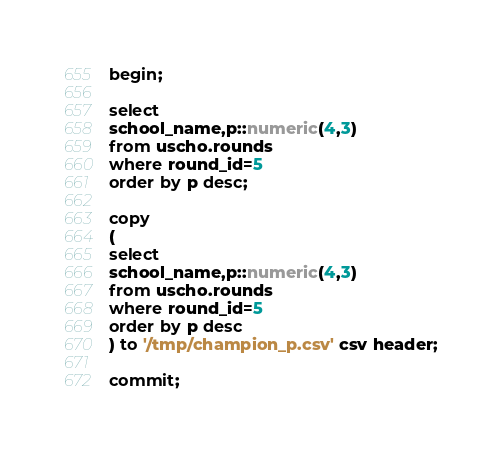<code> <loc_0><loc_0><loc_500><loc_500><_SQL_>begin;

select
school_name,p::numeric(4,3)
from uscho.rounds
where round_id=5
order by p desc;

copy
(
select
school_name,p::numeric(4,3)
from uscho.rounds
where round_id=5
order by p desc
) to '/tmp/champion_p.csv' csv header;

commit;
</code> 